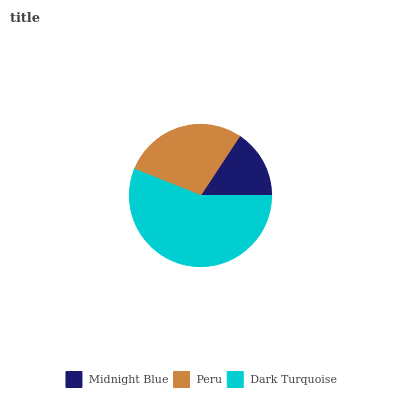Is Midnight Blue the minimum?
Answer yes or no. Yes. Is Dark Turquoise the maximum?
Answer yes or no. Yes. Is Peru the minimum?
Answer yes or no. No. Is Peru the maximum?
Answer yes or no. No. Is Peru greater than Midnight Blue?
Answer yes or no. Yes. Is Midnight Blue less than Peru?
Answer yes or no. Yes. Is Midnight Blue greater than Peru?
Answer yes or no. No. Is Peru less than Midnight Blue?
Answer yes or no. No. Is Peru the high median?
Answer yes or no. Yes. Is Peru the low median?
Answer yes or no. Yes. Is Midnight Blue the high median?
Answer yes or no. No. Is Dark Turquoise the low median?
Answer yes or no. No. 